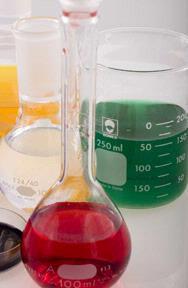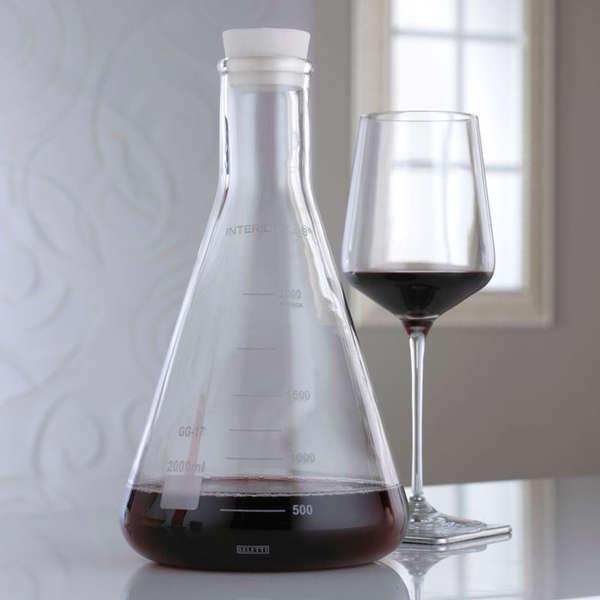The first image is the image on the left, the second image is the image on the right. Evaluate the accuracy of this statement regarding the images: "The right image includes a beaker containing bright red liquid.". Is it true? Answer yes or no. No. 